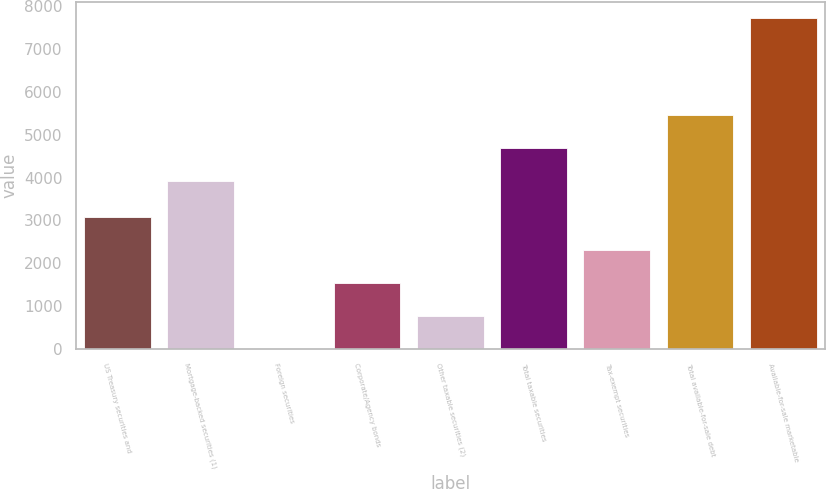Convert chart. <chart><loc_0><loc_0><loc_500><loc_500><bar_chart><fcel>US Treasury securities and<fcel>Mortgage-backed securities (1)<fcel>Foreign securities<fcel>Corporate/Agency bonds<fcel>Other taxable securities (2)<fcel>Total taxable securities<fcel>Tax-exempt securities<fcel>Total available-for-sale debt<fcel>Available-for-sale marketable<nl><fcel>3090.4<fcel>3924<fcel>6<fcel>1548.2<fcel>777.1<fcel>4695.1<fcel>2319.3<fcel>5466.2<fcel>7717<nl></chart> 